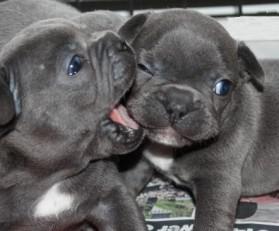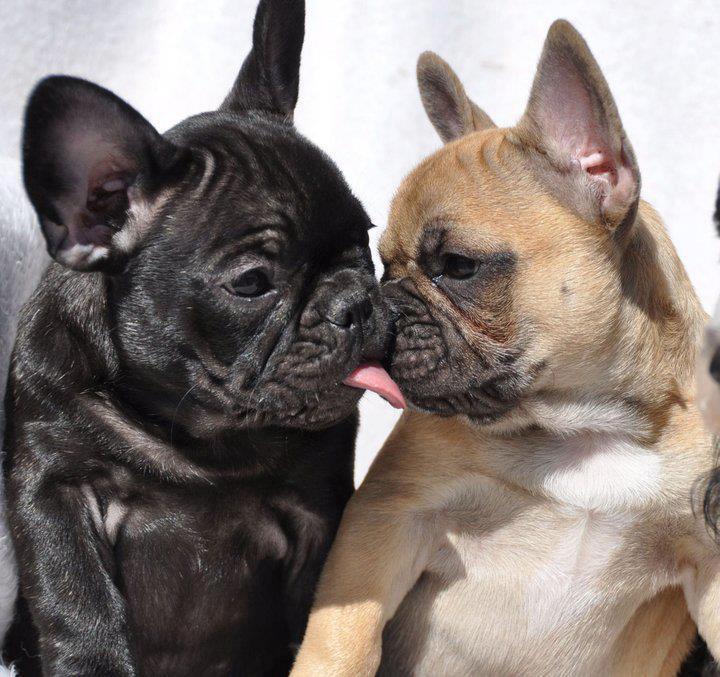The first image is the image on the left, the second image is the image on the right. Considering the images on both sides, is "Each image contains exactly two bulldogs, and the two dogs on the left are the same color, while the right image features a dark dog next to a lighter one." valid? Answer yes or no. Yes. The first image is the image on the left, the second image is the image on the right. Given the left and right images, does the statement "The left image contains exactly two dogs." hold true? Answer yes or no. Yes. 